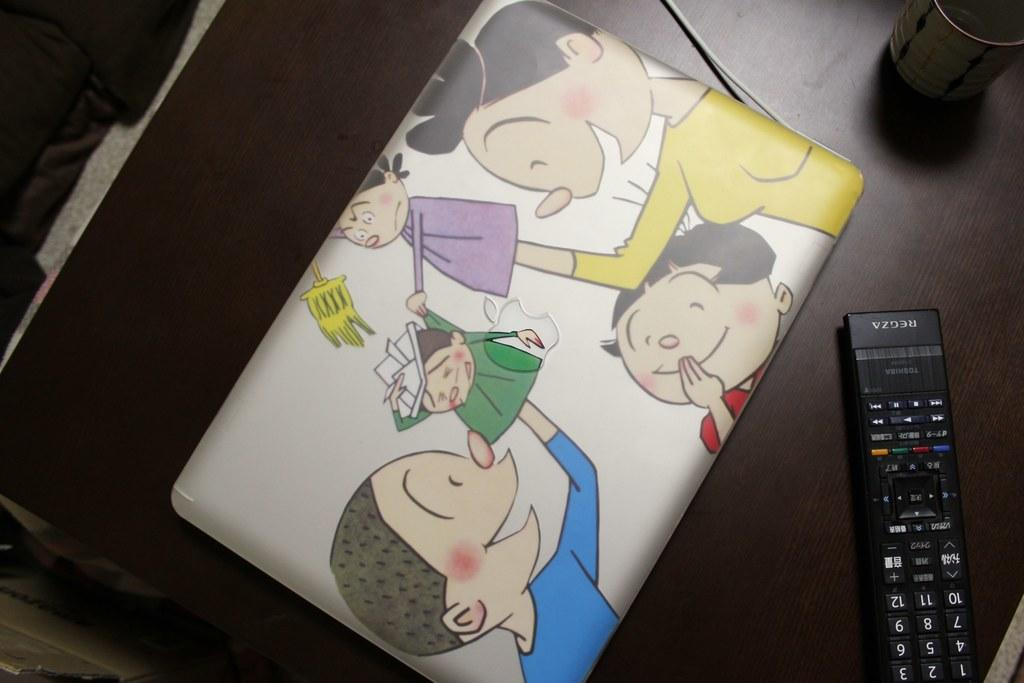Provide a one-sentence caption for the provided image. A colorful case with children playing next to a regza remote. 